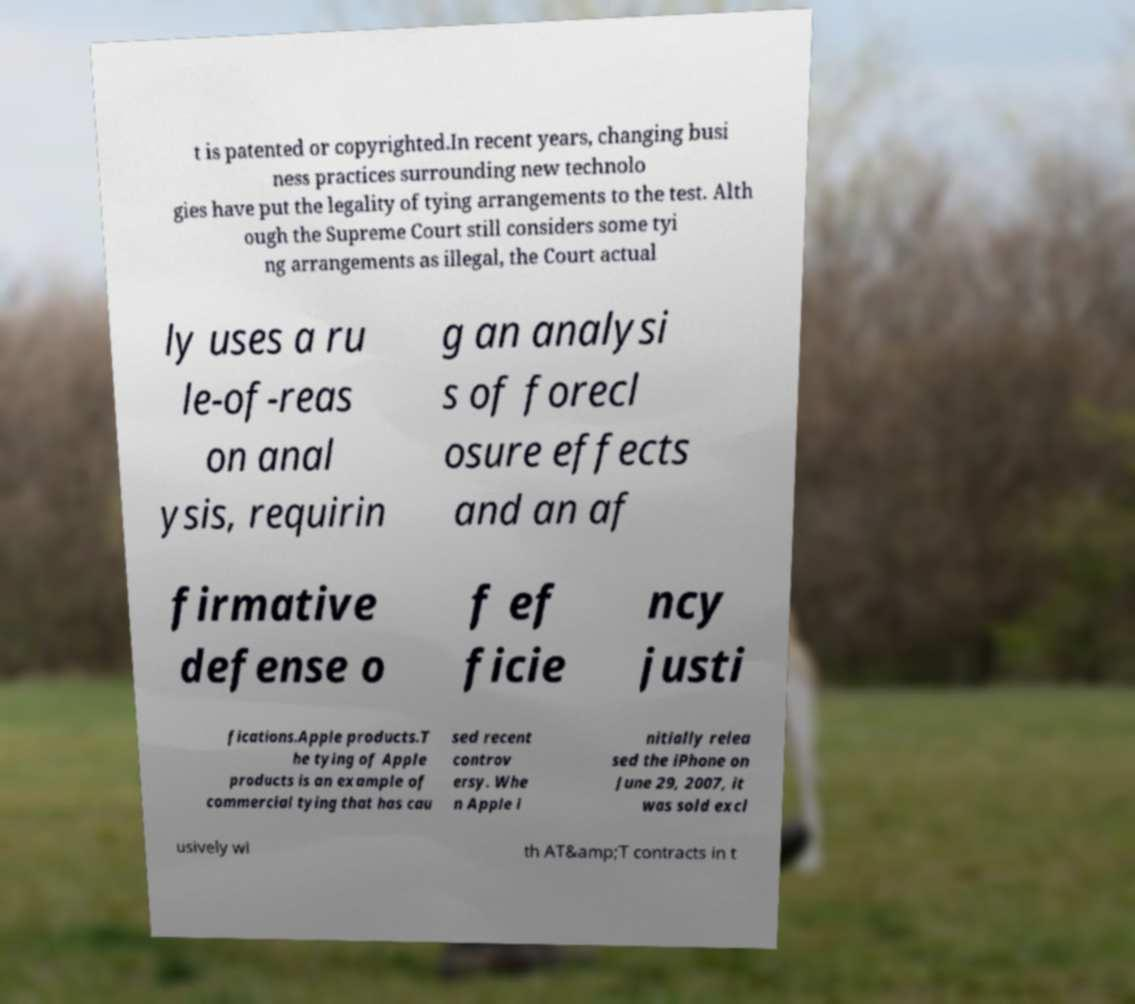Can you read and provide the text displayed in the image?This photo seems to have some interesting text. Can you extract and type it out for me? t is patented or copyrighted.In recent years, changing busi ness practices surrounding new technolo gies have put the legality of tying arrangements to the test. Alth ough the Supreme Court still considers some tyi ng arrangements as illegal, the Court actual ly uses a ru le-of-reas on anal ysis, requirin g an analysi s of forecl osure effects and an af firmative defense o f ef ficie ncy justi fications.Apple products.T he tying of Apple products is an example of commercial tying that has cau sed recent controv ersy. Whe n Apple i nitially relea sed the iPhone on June 29, 2007, it was sold excl usively wi th AT&amp;T contracts in t 